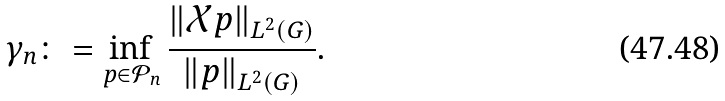Convert formula to latex. <formula><loc_0><loc_0><loc_500><loc_500>\gamma _ { n } \colon = \inf _ { p \in \mathcal { P } _ { n } } \frac { \| \mathcal { X } p \| _ { L ^ { 2 } ( G ) } } { \| p \| _ { L ^ { 2 } ( G ) } } .</formula> 